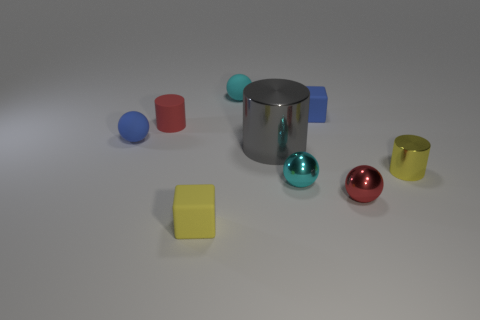Is there any other thing that is the same size as the gray shiny thing?
Keep it short and to the point. No. What is the material of the small cube in front of the small blue matte thing in front of the matte cylinder?
Your answer should be compact. Rubber. There is a large gray thing; are there any small cubes on the right side of it?
Give a very brief answer. Yes. Are there more spheres that are in front of the tiny blue ball than small metal spheres?
Give a very brief answer. No. Are there any large shiny cylinders of the same color as the tiny matte cylinder?
Your response must be concise. No. The other block that is the same size as the yellow cube is what color?
Offer a terse response. Blue. Is there a cyan object that is to the right of the small cyan sphere that is on the right side of the large object?
Give a very brief answer. No. There is a cyan ball that is to the right of the tiny cyan rubber object; what is it made of?
Make the answer very short. Metal. Is the material of the cylinder behind the big metallic thing the same as the red thing that is in front of the blue rubber sphere?
Keep it short and to the point. No. Are there the same number of rubber cylinders that are in front of the cyan metallic object and gray shiny cylinders in front of the yellow cylinder?
Your answer should be very brief. Yes. 